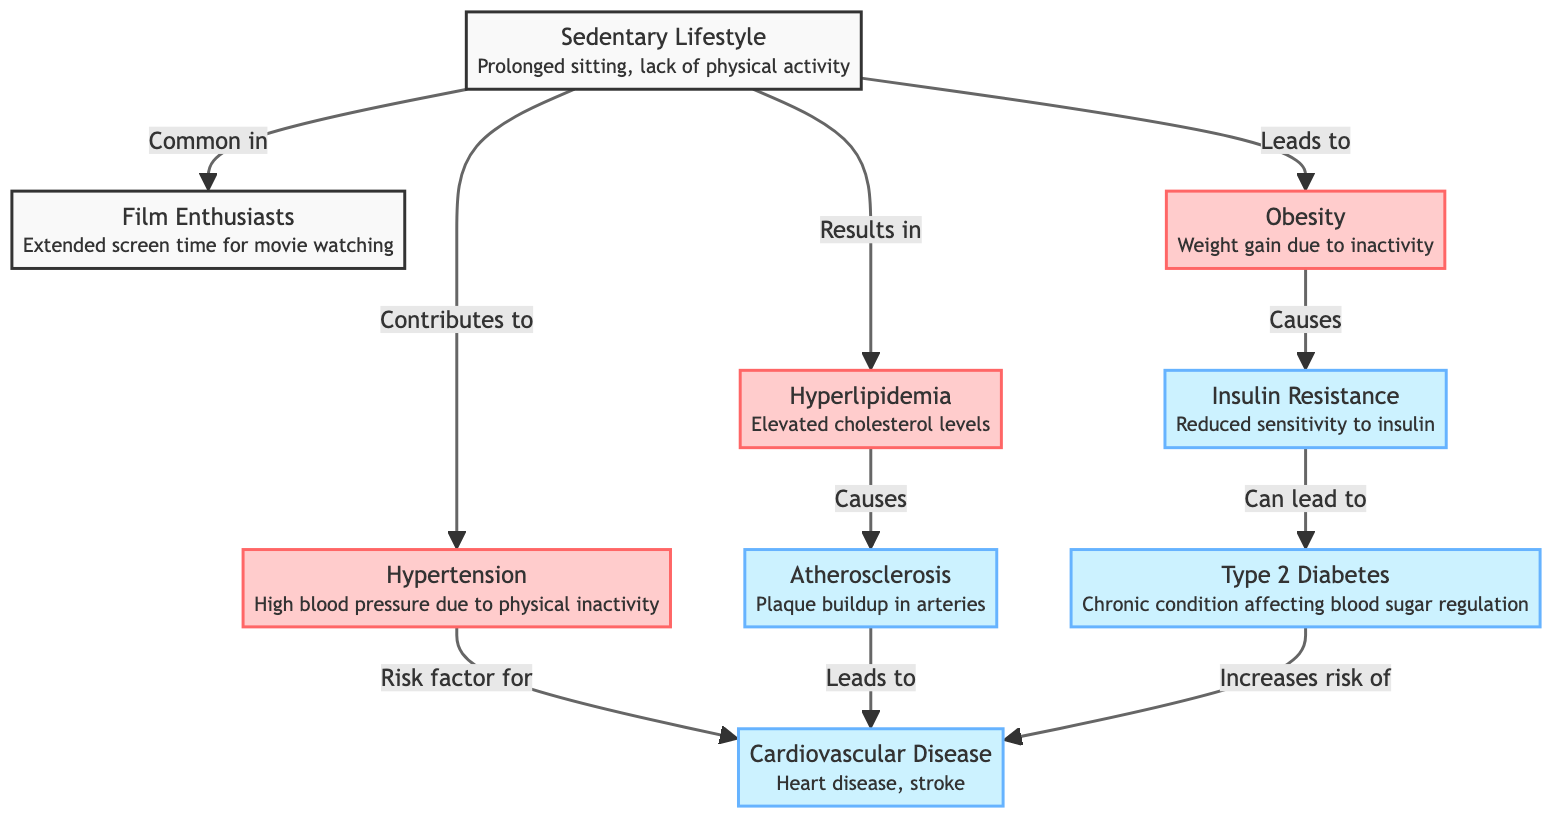What is the starting point of the diagram? The diagram starts with the node "Sedentary Lifestyle," which indicates the initial condition leading to various health factors.
Answer: Sedentary Lifestyle How many risk factors are identified in the diagram? There are three risk factors identified: obesity, hypertension, and hyperlipidemia. These are highlighted in red and contribute to serious conditions.
Answer: 3 What condition does hyperlipidemia cause? According to the diagram, hyperlipidemia causes atherosclerosis, which is the buildup of plaque in arteries, leading to serious cardiovascular issues.
Answer: Atherosclerosis Which risk factor is a consequence of obesity? The diagram shows that obesity causes insulin resistance, which is a significant factor in the development of Type 2 diabetes.
Answer: Insulin Resistance How does hypertension relate to cardiovascular disease? The diagram notes that hypertension is a risk factor for cardiovascular disease. This means that having high blood pressure increases the likelihood of developing heart disease or stroke.
Answer: Risk factor for cardiovascular disease What is the final condition that may result from multiple pathways? The final condition that may arise from various health issues including hypertension, diabetes, and atherosclerosis is cardiovascular disease, indicating severe health consequences from a sedentary lifestyle.
Answer: Cardiovascular Disease What role does insulin resistance play in the diagram? Insulin resistance results from obesity and can lead to Type 2 diabetes, showcasing a critical pathway in the diagram that connects these conditions.
Answer: Leads to Type 2 Diabetes How is atherosclerosis related to cardiovascular disease? Atherosclerosis directly leads to cardiovascular disease. The connection shows how plaque buildup can result in serious heart conditions like heart disease and stroke.
Answer: Leads to cardiovascular disease What contributes to hyperlipidemia in film enthusiasts? The diagram indicates that a sedentary lifestyle contributes to hyperlipidemia through prolonged inactivity and poor dietary habits possibly related to extended film viewing sessions.
Answer: Contributes to hyperlipidemia 